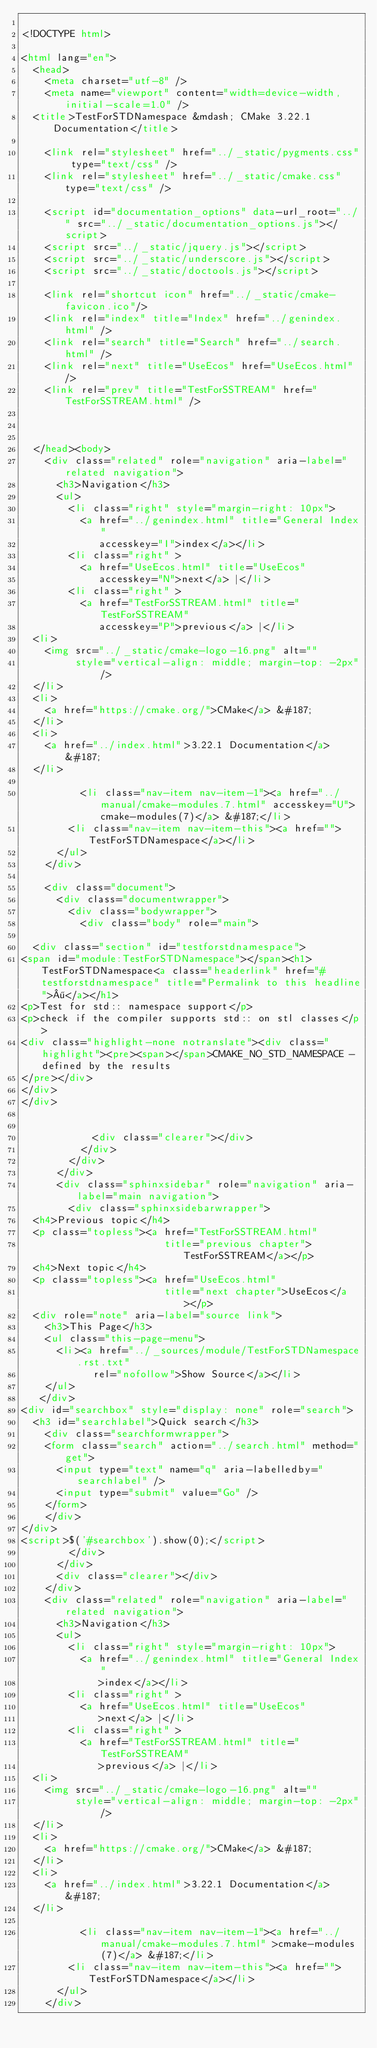Convert code to text. <code><loc_0><loc_0><loc_500><loc_500><_HTML_>
<!DOCTYPE html>

<html lang="en">
  <head>
    <meta charset="utf-8" />
    <meta name="viewport" content="width=device-width, initial-scale=1.0" />
  <title>TestForSTDNamespace &mdash; CMake 3.22.1 Documentation</title>

    <link rel="stylesheet" href="../_static/pygments.css" type="text/css" />
    <link rel="stylesheet" href="../_static/cmake.css" type="text/css" />
    
    <script id="documentation_options" data-url_root="../" src="../_static/documentation_options.js"></script>
    <script src="../_static/jquery.js"></script>
    <script src="../_static/underscore.js"></script>
    <script src="../_static/doctools.js"></script>
    
    <link rel="shortcut icon" href="../_static/cmake-favicon.ico"/>
    <link rel="index" title="Index" href="../genindex.html" />
    <link rel="search" title="Search" href="../search.html" />
    <link rel="next" title="UseEcos" href="UseEcos.html" />
    <link rel="prev" title="TestForSSTREAM" href="TestForSSTREAM.html" />
  
 

  </head><body>
    <div class="related" role="navigation" aria-label="related navigation">
      <h3>Navigation</h3>
      <ul>
        <li class="right" style="margin-right: 10px">
          <a href="../genindex.html" title="General Index"
             accesskey="I">index</a></li>
        <li class="right" >
          <a href="UseEcos.html" title="UseEcos"
             accesskey="N">next</a> |</li>
        <li class="right" >
          <a href="TestForSSTREAM.html" title="TestForSSTREAM"
             accesskey="P">previous</a> |</li>
  <li>
    <img src="../_static/cmake-logo-16.png" alt=""
         style="vertical-align: middle; margin-top: -2px" />
  </li>
  <li>
    <a href="https://cmake.org/">CMake</a> &#187;
  </li>
  <li>
    <a href="../index.html">3.22.1 Documentation</a> &#187;
  </li>

          <li class="nav-item nav-item-1"><a href="../manual/cmake-modules.7.html" accesskey="U">cmake-modules(7)</a> &#187;</li>
        <li class="nav-item nav-item-this"><a href="">TestForSTDNamespace</a></li> 
      </ul>
    </div>  

    <div class="document">
      <div class="documentwrapper">
        <div class="bodywrapper">
          <div class="body" role="main">
            
  <div class="section" id="testforstdnamespace">
<span id="module:TestForSTDNamespace"></span><h1>TestForSTDNamespace<a class="headerlink" href="#testforstdnamespace" title="Permalink to this headline">¶</a></h1>
<p>Test for std:: namespace support</p>
<p>check if the compiler supports std:: on stl classes</p>
<div class="highlight-none notranslate"><div class="highlight"><pre><span></span>CMAKE_NO_STD_NAMESPACE - defined by the results
</pre></div>
</div>
</div>


            <div class="clearer"></div>
          </div>
        </div>
      </div>
      <div class="sphinxsidebar" role="navigation" aria-label="main navigation">
        <div class="sphinxsidebarwrapper">
  <h4>Previous topic</h4>
  <p class="topless"><a href="TestForSSTREAM.html"
                        title="previous chapter">TestForSSTREAM</a></p>
  <h4>Next topic</h4>
  <p class="topless"><a href="UseEcos.html"
                        title="next chapter">UseEcos</a></p>
  <div role="note" aria-label="source link">
    <h3>This Page</h3>
    <ul class="this-page-menu">
      <li><a href="../_sources/module/TestForSTDNamespace.rst.txt"
            rel="nofollow">Show Source</a></li>
    </ul>
   </div>
<div id="searchbox" style="display: none" role="search">
  <h3 id="searchlabel">Quick search</h3>
    <div class="searchformwrapper">
    <form class="search" action="../search.html" method="get">
      <input type="text" name="q" aria-labelledby="searchlabel" />
      <input type="submit" value="Go" />
    </form>
    </div>
</div>
<script>$('#searchbox').show(0);</script>
        </div>
      </div>
      <div class="clearer"></div>
    </div>
    <div class="related" role="navigation" aria-label="related navigation">
      <h3>Navigation</h3>
      <ul>
        <li class="right" style="margin-right: 10px">
          <a href="../genindex.html" title="General Index"
             >index</a></li>
        <li class="right" >
          <a href="UseEcos.html" title="UseEcos"
             >next</a> |</li>
        <li class="right" >
          <a href="TestForSSTREAM.html" title="TestForSSTREAM"
             >previous</a> |</li>
  <li>
    <img src="../_static/cmake-logo-16.png" alt=""
         style="vertical-align: middle; margin-top: -2px" />
  </li>
  <li>
    <a href="https://cmake.org/">CMake</a> &#187;
  </li>
  <li>
    <a href="../index.html">3.22.1 Documentation</a> &#187;
  </li>

          <li class="nav-item nav-item-1"><a href="../manual/cmake-modules.7.html" >cmake-modules(7)</a> &#187;</li>
        <li class="nav-item nav-item-this"><a href="">TestForSTDNamespace</a></li> 
      </ul>
    </div></code> 